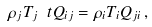<formula> <loc_0><loc_0><loc_500><loc_500>\rho _ { j } T _ { j } \ t Q _ { i j } = \rho _ { i } T _ { i } Q _ { j i } \, ,</formula> 